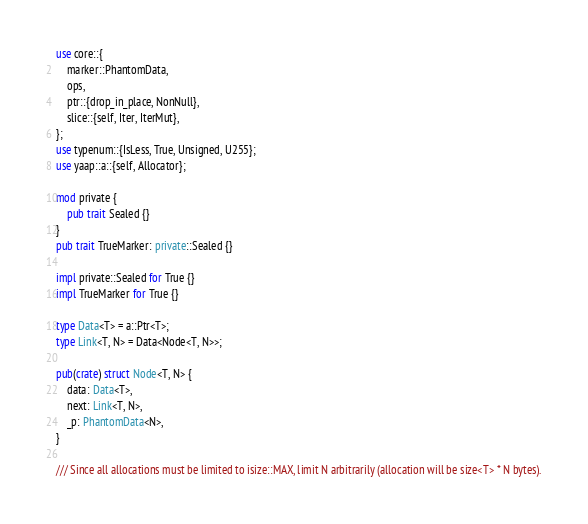<code> <loc_0><loc_0><loc_500><loc_500><_Rust_>use core::{
    marker::PhantomData,
    ops,
    ptr::{drop_in_place, NonNull},
    slice::{self, Iter, IterMut},
};
use typenum::{IsLess, True, Unsigned, U255};
use yaap::a::{self, Allocator};

mod private {
    pub trait Sealed {}
}
pub trait TrueMarker: private::Sealed {}

impl private::Sealed for True {}
impl TrueMarker for True {}

type Data<T> = a::Ptr<T>;
type Link<T, N> = Data<Node<T, N>>;

pub(crate) struct Node<T, N> {
    data: Data<T>,
    next: Link<T, N>,
    _p: PhantomData<N>,
}

/// Since all allocations must be limited to isize::MAX, limit N arbitrarily (allocation will be size<T> * N bytes).</code> 